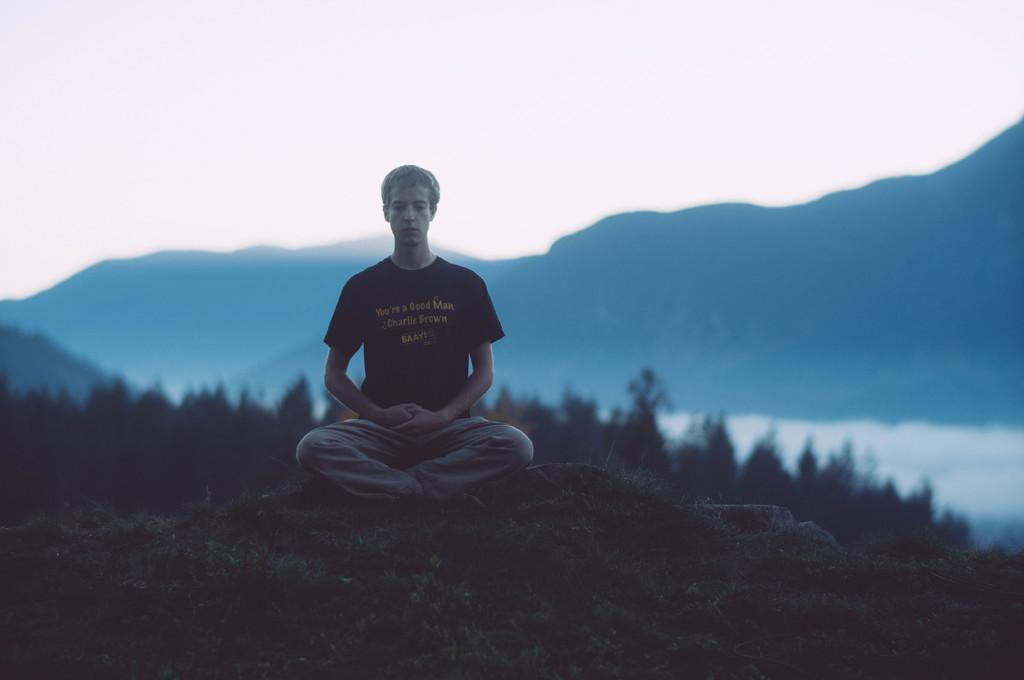Who is the person in the image? There is a man in the image. What is the man doing in the image? The man is meditating. Where is the man located in the image? The man is on a hill. What can be seen in the background of the image? There are hills visible in the background of the image. What is visible above the hills in the image? The sky is visible in the image. What type of food is the man eating while meditating in the image? There is no food present in the image; the man is meditating. What is the condition of the basketball court in the image? There is no basketball court present in the image. 